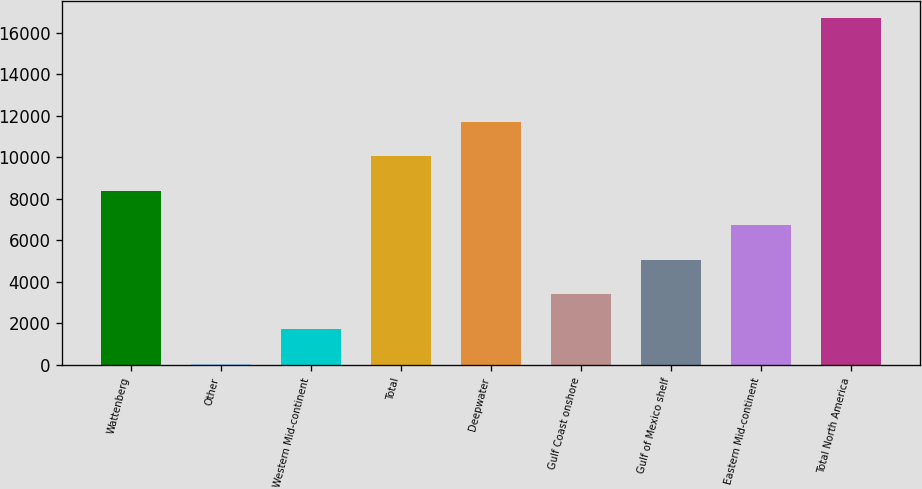Convert chart. <chart><loc_0><loc_0><loc_500><loc_500><bar_chart><fcel>Wattenberg<fcel>Other<fcel>Western Mid-continent<fcel>Total<fcel>Deepwater<fcel>Gulf Coast onshore<fcel>Gulf of Mexico shelf<fcel>Eastern Mid-continent<fcel>Total North America<nl><fcel>8383<fcel>51<fcel>1717.4<fcel>10049.4<fcel>11715.8<fcel>3383.8<fcel>5050.2<fcel>6716.6<fcel>16715<nl></chart> 